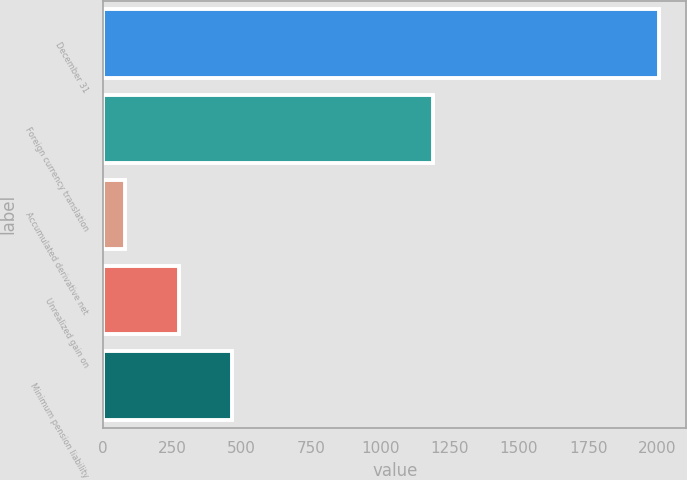<chart> <loc_0><loc_0><loc_500><loc_500><bar_chart><fcel>December 31<fcel>Foreign currency translation<fcel>Accumulated derivative net<fcel>Unrealized gain on<fcel>Minimum pension liability<nl><fcel>2004<fcel>1191<fcel>80<fcel>272.4<fcel>464.8<nl></chart> 